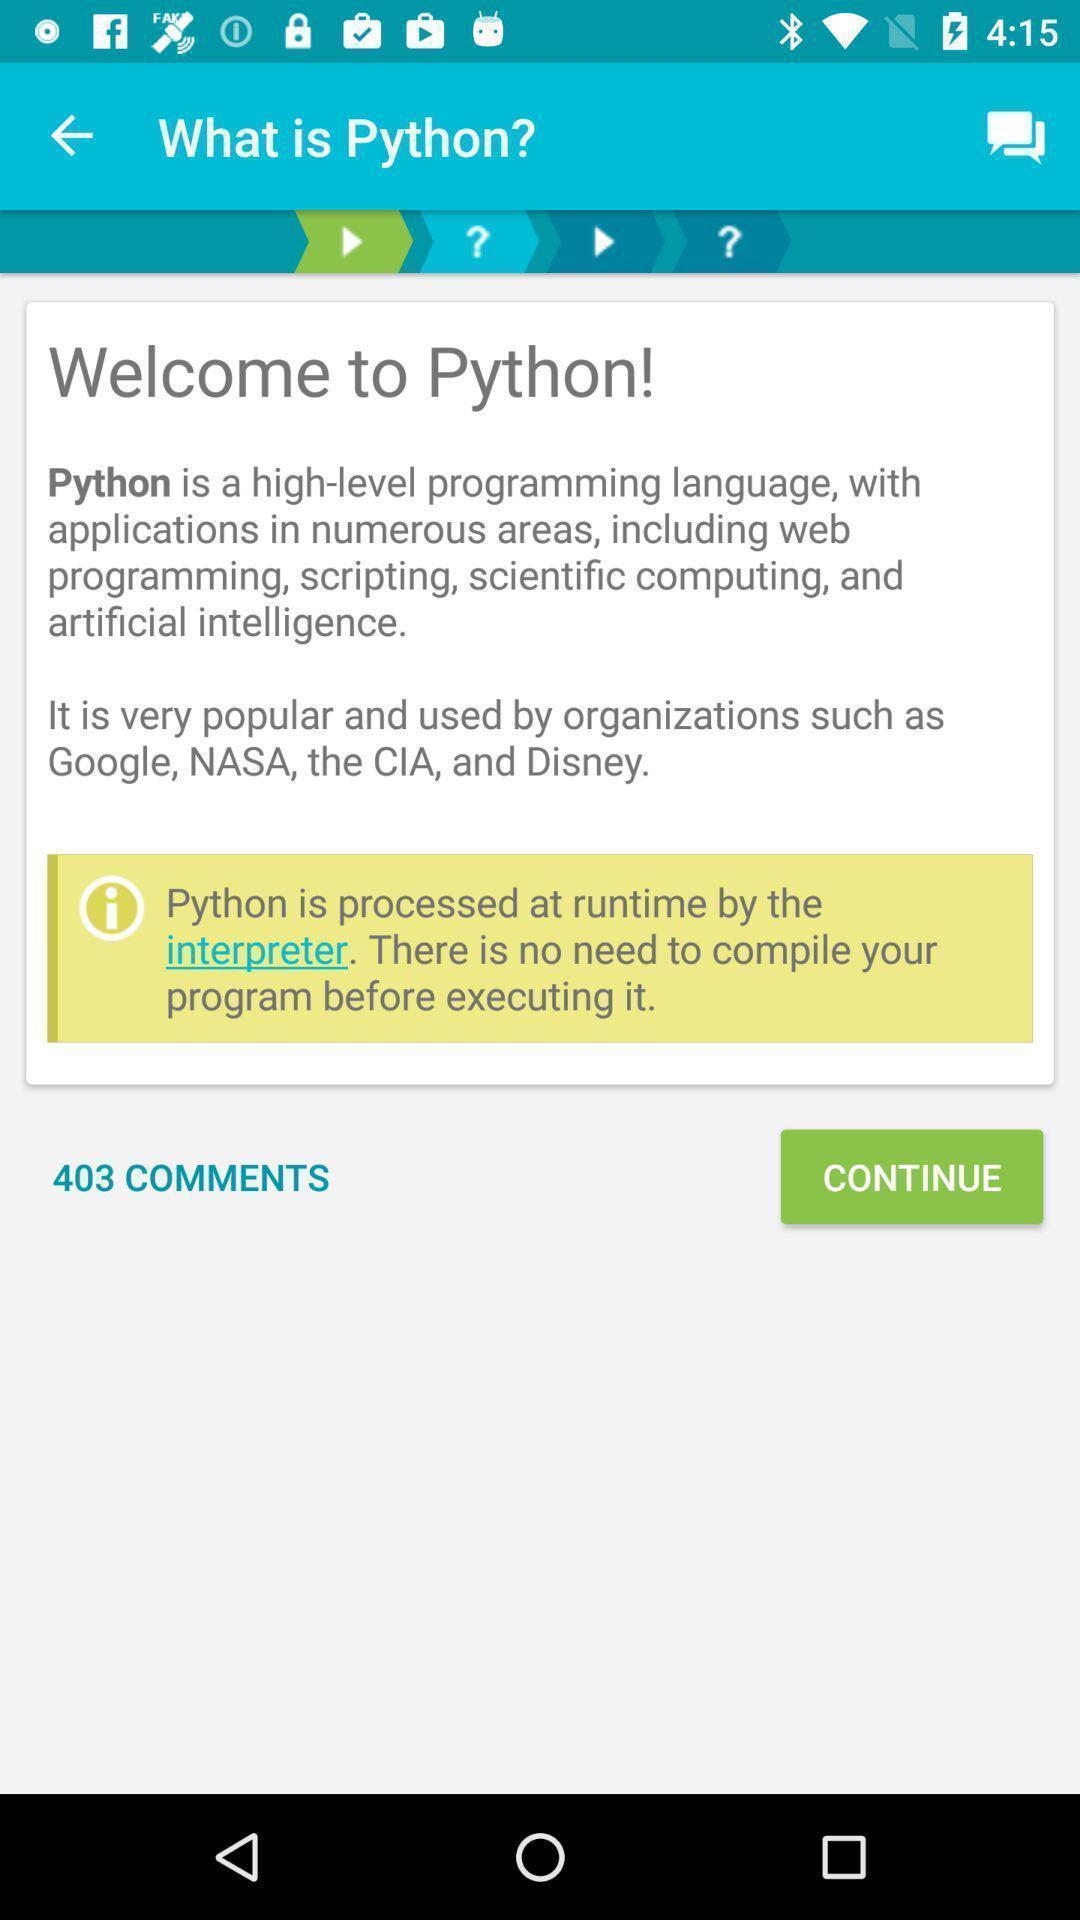Summarize the information in this screenshot. Welcome page. 